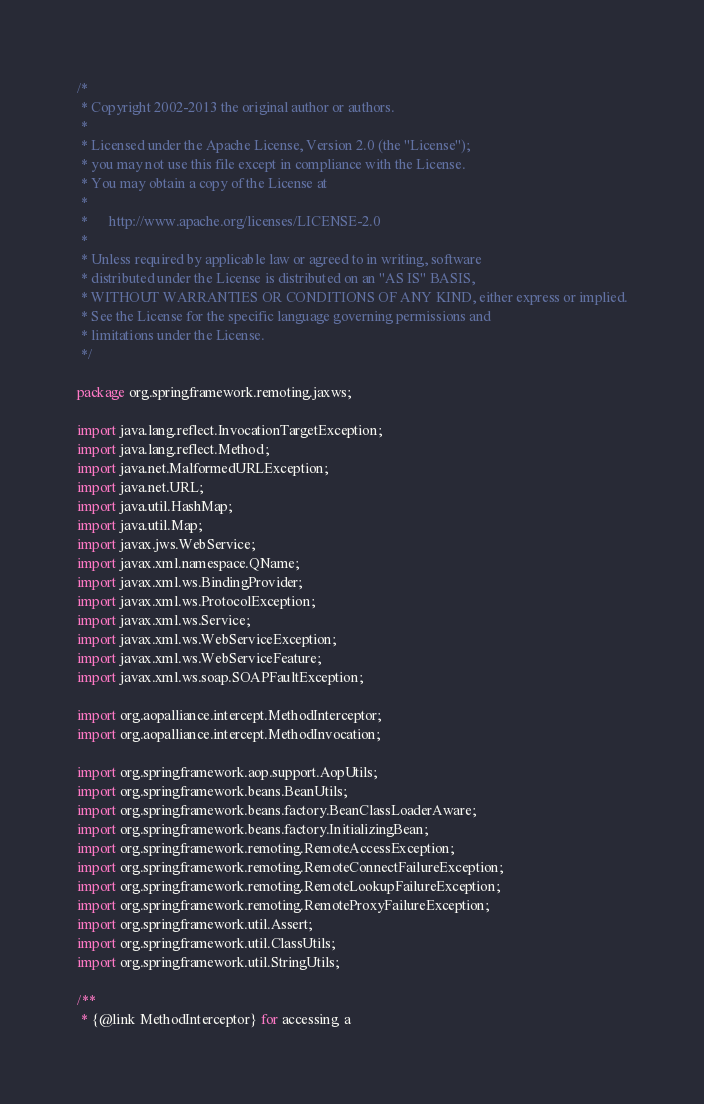<code> <loc_0><loc_0><loc_500><loc_500><_Java_>/*
 * Copyright 2002-2013 the original author or authors.
 *
 * Licensed under the Apache License, Version 2.0 (the "License");
 * you may not use this file except in compliance with the License.
 * You may obtain a copy of the License at
 *
 *      http://www.apache.org/licenses/LICENSE-2.0
 *
 * Unless required by applicable law or agreed to in writing, software
 * distributed under the License is distributed on an "AS IS" BASIS,
 * WITHOUT WARRANTIES OR CONDITIONS OF ANY KIND, either express or implied.
 * See the License for the specific language governing permissions and
 * limitations under the License.
 */

package org.springframework.remoting.jaxws;

import java.lang.reflect.InvocationTargetException;
import java.lang.reflect.Method;
import java.net.MalformedURLException;
import java.net.URL;
import java.util.HashMap;
import java.util.Map;
import javax.jws.WebService;
import javax.xml.namespace.QName;
import javax.xml.ws.BindingProvider;
import javax.xml.ws.ProtocolException;
import javax.xml.ws.Service;
import javax.xml.ws.WebServiceException;
import javax.xml.ws.WebServiceFeature;
import javax.xml.ws.soap.SOAPFaultException;

import org.aopalliance.intercept.MethodInterceptor;
import org.aopalliance.intercept.MethodInvocation;

import org.springframework.aop.support.AopUtils;
import org.springframework.beans.BeanUtils;
import org.springframework.beans.factory.BeanClassLoaderAware;
import org.springframework.beans.factory.InitializingBean;
import org.springframework.remoting.RemoteAccessException;
import org.springframework.remoting.RemoteConnectFailureException;
import org.springframework.remoting.RemoteLookupFailureException;
import org.springframework.remoting.RemoteProxyFailureException;
import org.springframework.util.Assert;
import org.springframework.util.ClassUtils;
import org.springframework.util.StringUtils;

/**
 * {@link MethodInterceptor} for accessing a</code> 